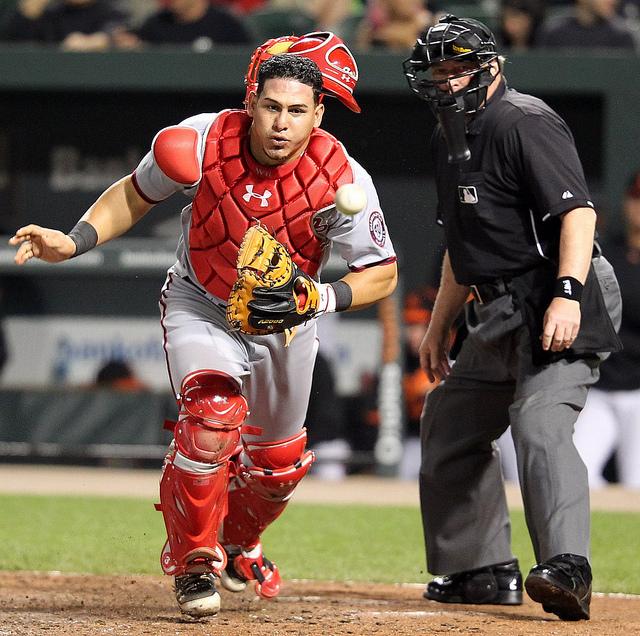What color is his vest?
Be succinct. Red. Is the ball coming towards the catcher?
Be succinct. Yes. What color are his shin guards?
Concise answer only. Red. 